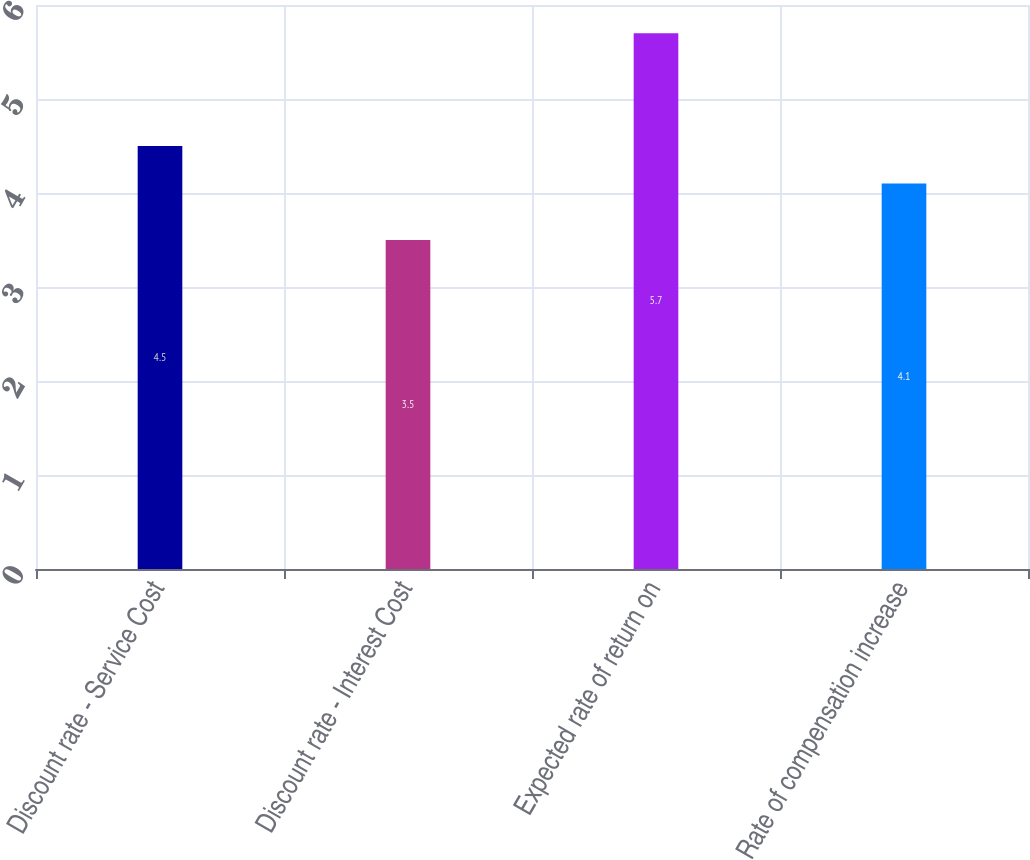Convert chart to OTSL. <chart><loc_0><loc_0><loc_500><loc_500><bar_chart><fcel>Discount rate - Service Cost<fcel>Discount rate - Interest Cost<fcel>Expected rate of return on<fcel>Rate of compensation increase<nl><fcel>4.5<fcel>3.5<fcel>5.7<fcel>4.1<nl></chart> 